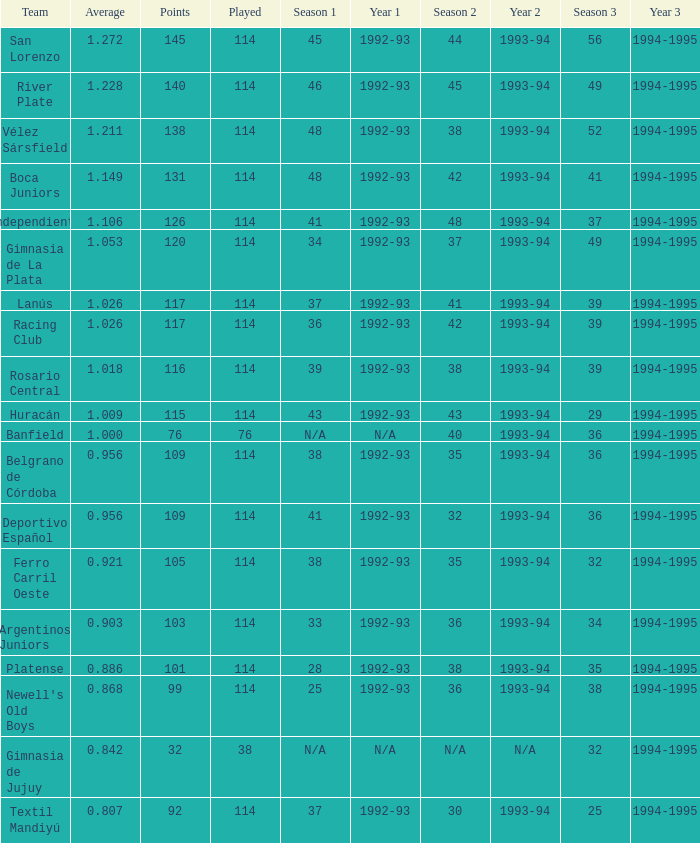Name the team for 1993-94 for 32 Deportivo Español. 